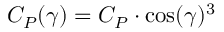<formula> <loc_0><loc_0><loc_500><loc_500>C _ { P } ( \gamma ) = C _ { P } \cdot \cos ( \gamma ) ^ { 3 }</formula> 